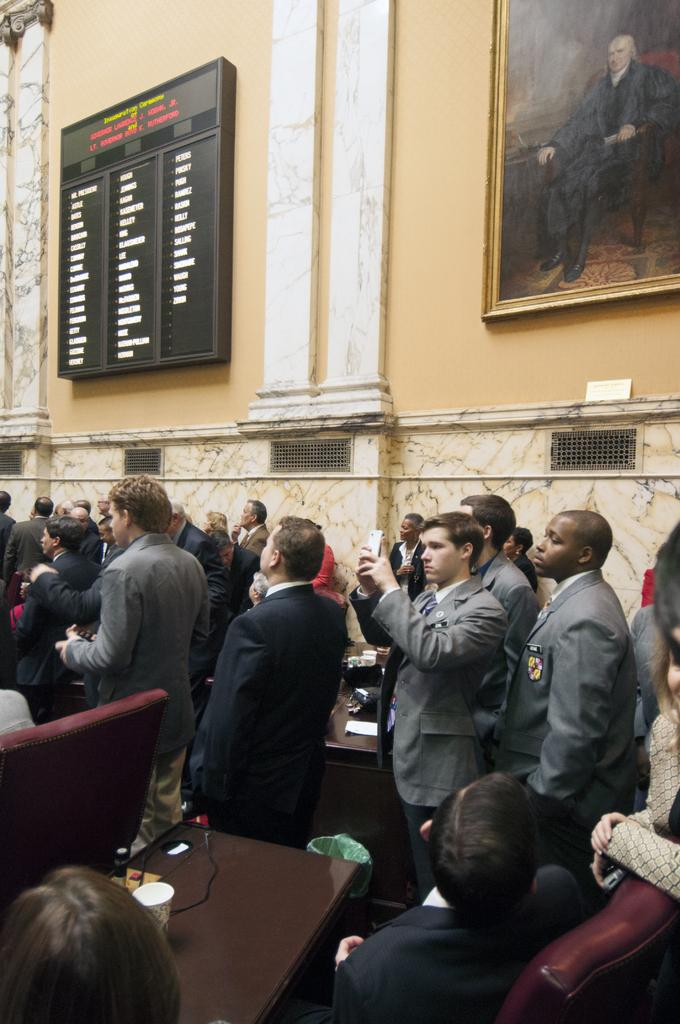What object is located on the right side of the picture? There is a frame and a board on the right side of the picture. What can be seen in the image besides the frame and board? There are people standing in the image and chairs are also visible. Where is the hen sitting in the image? There is no hen present in the image. What is the thumb used for in the image? There is no thumb visible in the image. 